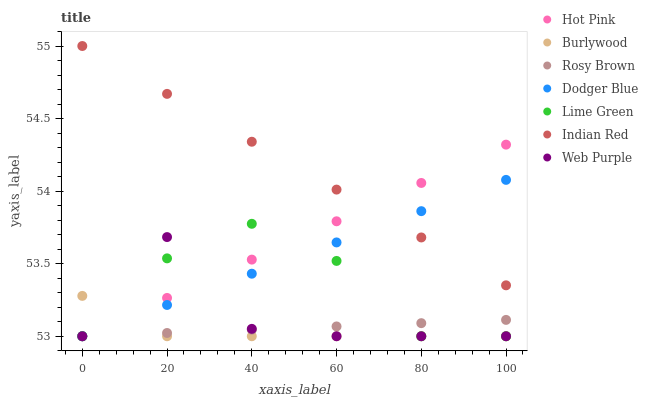Does Burlywood have the minimum area under the curve?
Answer yes or no. Yes. Does Indian Red have the maximum area under the curve?
Answer yes or no. Yes. Does Rosy Brown have the minimum area under the curve?
Answer yes or no. No. Does Rosy Brown have the maximum area under the curve?
Answer yes or no. No. Is Hot Pink the smoothest?
Answer yes or no. Yes. Is Web Purple the roughest?
Answer yes or no. Yes. Is Burlywood the smoothest?
Answer yes or no. No. Is Burlywood the roughest?
Answer yes or no. No. Does Hot Pink have the lowest value?
Answer yes or no. Yes. Does Indian Red have the lowest value?
Answer yes or no. No. Does Indian Red have the highest value?
Answer yes or no. Yes. Does Burlywood have the highest value?
Answer yes or no. No. Is Burlywood less than Indian Red?
Answer yes or no. Yes. Is Indian Red greater than Lime Green?
Answer yes or no. Yes. Does Dodger Blue intersect Indian Red?
Answer yes or no. Yes. Is Dodger Blue less than Indian Red?
Answer yes or no. No. Is Dodger Blue greater than Indian Red?
Answer yes or no. No. Does Burlywood intersect Indian Red?
Answer yes or no. No. 